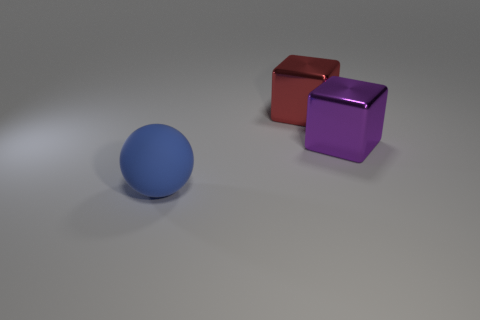Are there fewer blue rubber objects on the left side of the blue object than blue objects to the left of the large purple metallic cube?
Offer a very short reply. Yes. Is there anything else that has the same shape as the blue object?
Provide a succinct answer. No. Is the shape of the large red metal thing the same as the purple object?
Your response must be concise. Yes. Are there any other things that have the same material as the big blue thing?
Give a very brief answer. No. What color is the object that is both behind the large blue matte sphere and in front of the big red metal cube?
Give a very brief answer. Purple. Is the number of purple metal things greater than the number of small brown things?
Your answer should be very brief. Yes. What number of things are either brown things or large blue rubber spheres left of the red metallic block?
Ensure brevity in your answer.  1. Do the rubber ball and the purple shiny block have the same size?
Provide a succinct answer. Yes. Are there any metallic objects to the left of the big red metal cube?
Make the answer very short. No. What size is the thing that is to the left of the large purple metal block and behind the large blue sphere?
Ensure brevity in your answer.  Large. 